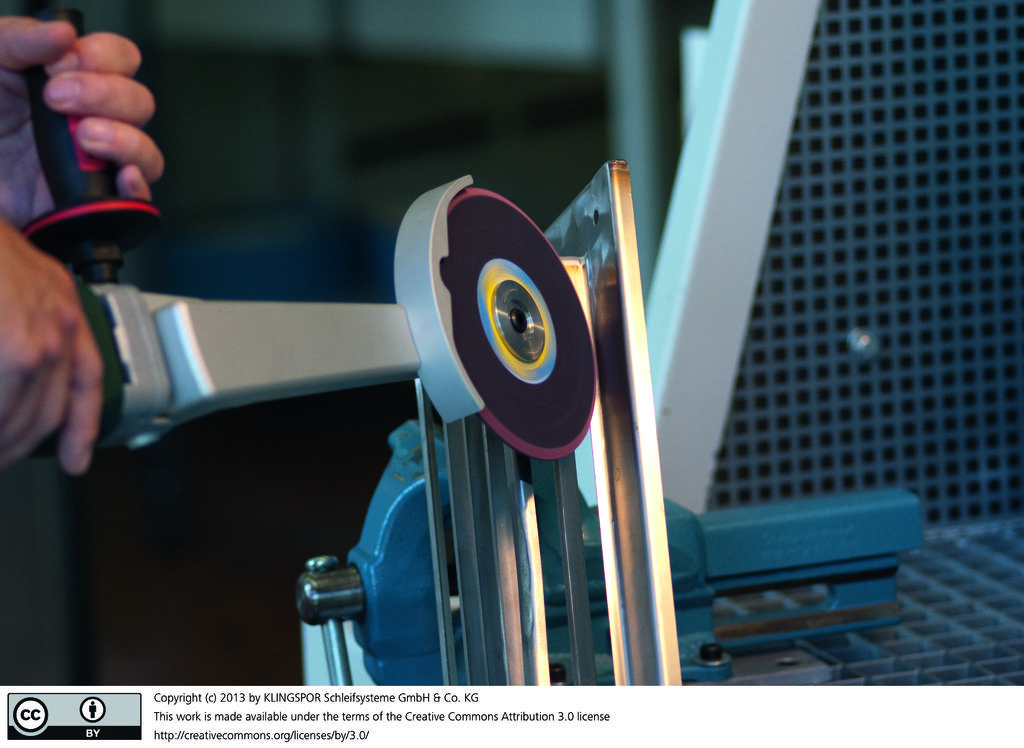What is the person holding in the image? There are two hands of a person holding an object in the image. What color is the background of the object? The background of the object is blue. What else can be seen in the image? There is some text in the image. Are there any identifiable symbols in the image? Yes, there are two logos at the bottom of the image. Can you see a tiger in the image? No, there is no tiger present in the image. 